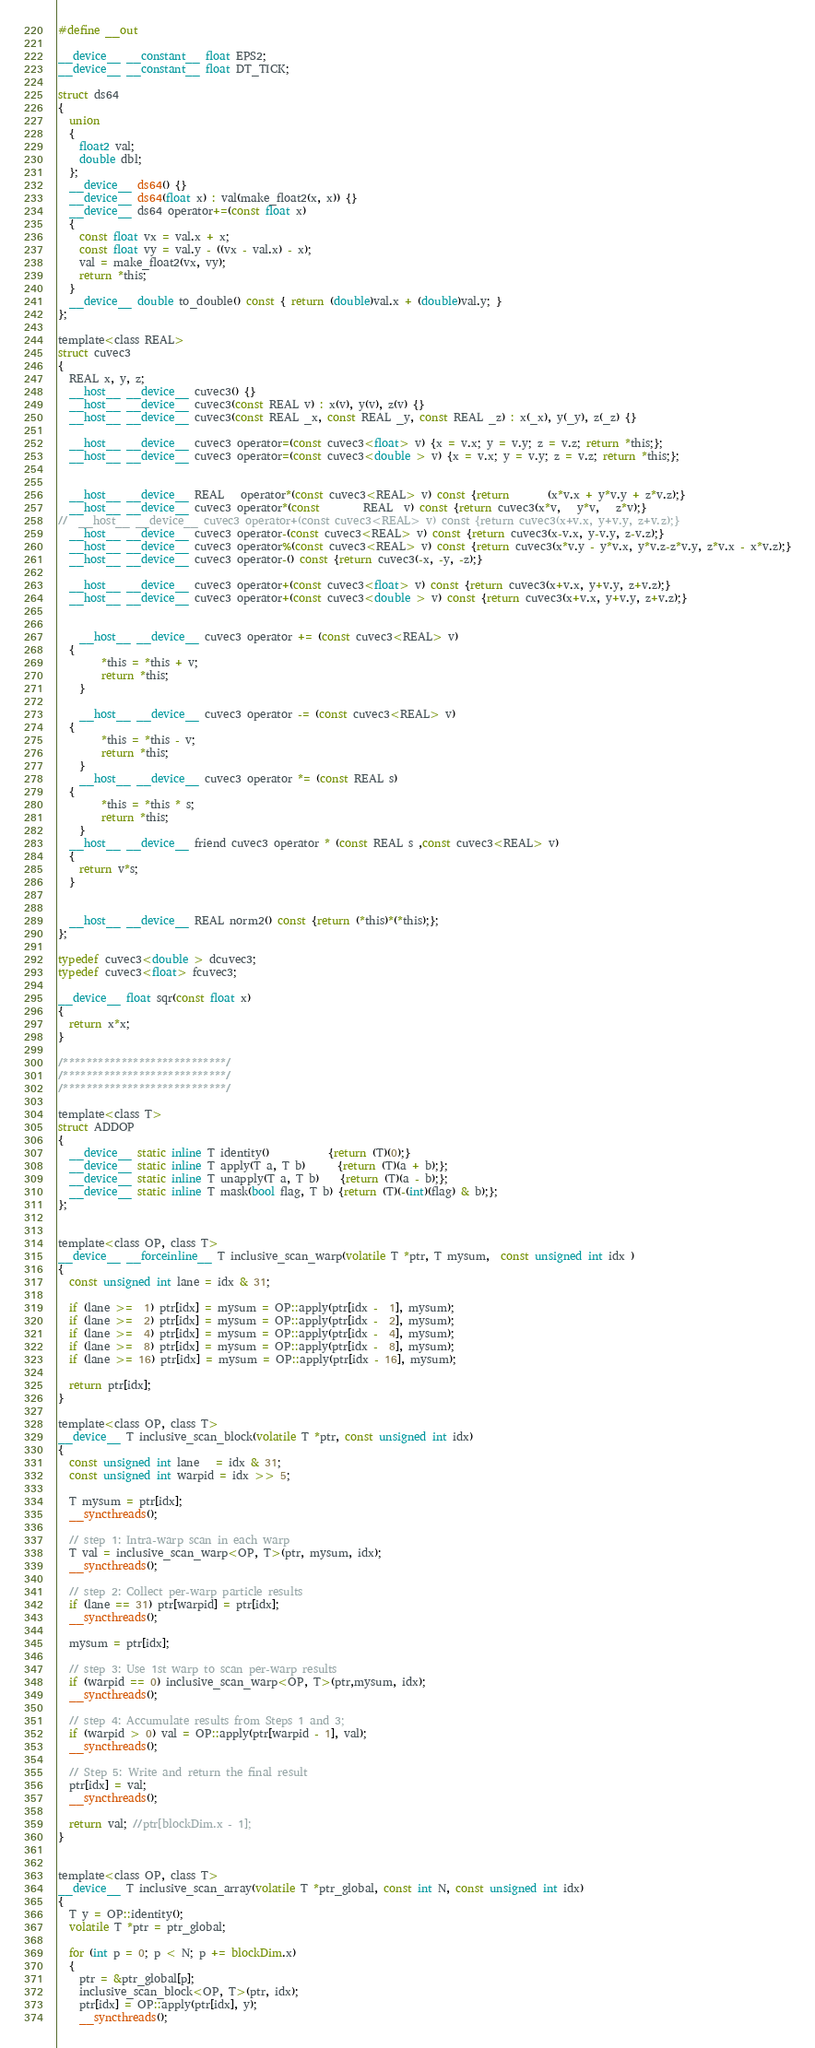<code> <loc_0><loc_0><loc_500><loc_500><_Cuda_>#define __out 

__device__ __constant__ float EPS2;
__device__ __constant__ float DT_TICK;

struct ds64
{
  union
  {
    float2 val;
    double dbl;
  };
  __device__ ds64() {}
  __device__ ds64(float x) : val(make_float2(x, x)) {}
  __device__ ds64 operator+=(const float x) 
  {
    const float vx = val.x + x;
    const float vy = val.y - ((vx - val.x) - x);
    val = make_float2(vx, vy);
    return *this;
  }
  __device__ double to_double() const { return (double)val.x + (double)val.y; }
};

template<class REAL>
struct cuvec3
{
  REAL x, y, z;
  __host__ __device__ cuvec3() {}
  __host__ __device__ cuvec3(const REAL v) : x(v), y(v), z(v) {}
  __host__ __device__ cuvec3(const REAL _x, const REAL _y, const REAL _z) : x(_x), y(_y), z(_z) {}
  
  __host__ __device__ cuvec3 operator=(const cuvec3<float> v) {x = v.x; y = v.y; z = v.z; return *this;};
  __host__ __device__ cuvec3 operator=(const cuvec3<double > v) {x = v.x; y = v.y; z = v.z; return *this;};
  

  __host__ __device__ REAL   operator*(const cuvec3<REAL> v) const {return       (x*v.x + y*v.y + z*v.z);}
  __host__ __device__ cuvec3 operator*(const        REAL  v) const {return cuvec3(x*v,   y*v,   z*v);}
//  __host__ __device__ cuvec3 operator+(const cuvec3<REAL> v) const {return cuvec3(x+v.x, y+v.y, z+v.z);}
  __host__ __device__ cuvec3 operator-(const cuvec3<REAL> v) const {return cuvec3(x-v.x, y-v.y, z-v.z);}
  __host__ __device__ cuvec3 operator%(const cuvec3<REAL> v) const {return cuvec3(x*v.y - y*v.x, y*v.z-z*v.y, z*v.x - x*v.z);}
  __host__ __device__ cuvec3 operator-() const {return cuvec3(-x, -y, -z);}
  
  __host__ __device__ cuvec3 operator+(const cuvec3<float> v) const {return cuvec3(x+v.x, y+v.y, z+v.z);}
  __host__ __device__ cuvec3 operator+(const cuvec3<double > v) const {return cuvec3(x+v.x, y+v.y, z+v.z);}


	__host__ __device__ cuvec3 operator += (const cuvec3<REAL> v)
  {
		*this = *this + v;
		return *this;
	}

	__host__ __device__ cuvec3 operator -= (const cuvec3<REAL> v)
  {
		*this = *this - v;
		return *this;
	}
	__host__ __device__ cuvec3 operator *= (const REAL s)
  {
		*this = *this * s;
		return *this;
	}
  __host__ __device__ friend cuvec3 operator * (const REAL s ,const cuvec3<REAL> v)
  {
    return v*s;
  }


  __host__ __device__ REAL norm2() const {return (*this)*(*this);};
};

typedef cuvec3<double > dcuvec3;
typedef cuvec3<float> fcuvec3;

__device__ float sqr(const float x)
{
  return x*x;
}

/****************************/
/****************************/
/****************************/

template<class T>
struct ADDOP 
{
  __device__ static inline T identity()           {return (T)(0);}
  __device__ static inline T apply(T a, T b)      {return (T)(a + b);};
  __device__ static inline T unapply(T a, T b)    {return (T)(a - b);};
  __device__ static inline T mask(bool flag, T b) {return (T)(-(int)(flag) & b);};
};


template<class OP, class T>
__device__ __forceinline__ T inclusive_scan_warp(volatile T *ptr, T mysum,  const unsigned int idx ) 
{
  const unsigned int lane = idx & 31;

  if (lane >=  1) ptr[idx] = mysum = OP::apply(ptr[idx -  1], mysum);
  if (lane >=  2) ptr[idx] = mysum = OP::apply(ptr[idx -  2], mysum);
  if (lane >=  4) ptr[idx] = mysum = OP::apply(ptr[idx -  4], mysum);
  if (lane >=  8) ptr[idx] = mysum = OP::apply(ptr[idx -  8], mysum);
  if (lane >= 16) ptr[idx] = mysum = OP::apply(ptr[idx - 16], mysum);

  return ptr[idx];
}

template<class OP, class T>
__device__ T inclusive_scan_block(volatile T *ptr, const unsigned int idx) 
{
  const unsigned int lane   = idx & 31;
  const unsigned int warpid = idx >> 5;

  T mysum = ptr[idx];
  __syncthreads();

  // step 1: Intra-warp scan in each warp
  T val = inclusive_scan_warp<OP, T>(ptr, mysum, idx);
  __syncthreads();

  // step 2: Collect per-warp particle results
  if (lane == 31) ptr[warpid] = ptr[idx];
  __syncthreads();

  mysum = ptr[idx];

  // step 3: Use 1st warp to scan per-warp results
  if (warpid == 0) inclusive_scan_warp<OP, T>(ptr,mysum, idx);
  __syncthreads();

  // step 4: Accumulate results from Steps 1 and 3;
  if (warpid > 0) val = OP::apply(ptr[warpid - 1], val);
  __syncthreads();

  // Step 5: Write and return the final result
  ptr[idx] = val;
  __syncthreads();

  return val; //ptr[blockDim.x - 1];
}


template<class OP, class T>
__device__ T inclusive_scan_array(volatile T *ptr_global, const int N, const unsigned int idx) 
{
  T y = OP::identity();
  volatile T *ptr = ptr_global;

  for (int p = 0; p < N; p += blockDim.x) 
  {
    ptr = &ptr_global[p];
    inclusive_scan_block<OP, T>(ptr, idx);
    ptr[idx] = OP::apply(ptr[idx], y);
    __syncthreads();
</code> 